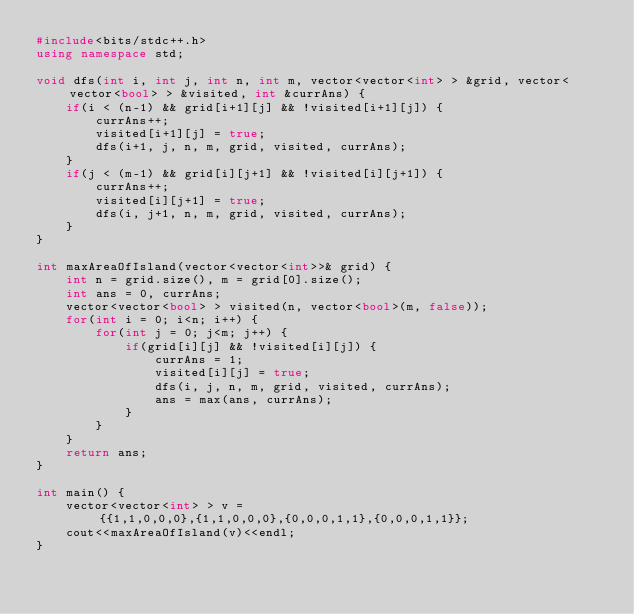<code> <loc_0><loc_0><loc_500><loc_500><_C++_>#include<bits/stdc++.h>
using namespace std;

void dfs(int i, int j, int n, int m, vector<vector<int> > &grid, vector<vector<bool> > &visited, int &currAns) {
    if(i < (n-1) && grid[i+1][j] && !visited[i+1][j]) {
        currAns++;
        visited[i+1][j] = true;
        dfs(i+1, j, n, m, grid, visited, currAns);
    }
    if(j < (m-1) && grid[i][j+1] && !visited[i][j+1]) {
        currAns++;
        visited[i][j+1] = true;
        dfs(i, j+1, n, m, grid, visited, currAns);
    }
}

int maxAreaOfIsland(vector<vector<int>>& grid) {
    int n = grid.size(), m = grid[0].size();
    int ans = 0, currAns;
    vector<vector<bool> > visited(n, vector<bool>(m, false));
    for(int i = 0; i<n; i++) {
        for(int j = 0; j<m; j++) {
            if(grid[i][j] && !visited[i][j]) {
                currAns = 1;
                visited[i][j] = true;
                dfs(i, j, n, m, grid, visited, currAns);
                ans = max(ans, currAns);
            }
        }
    }
    return ans;
}

int main() {
    vector<vector<int> > v = {{1,1,0,0,0},{1,1,0,0,0},{0,0,0,1,1},{0,0,0,1,1}};
    cout<<maxAreaOfIsland(v)<<endl;
}
</code> 